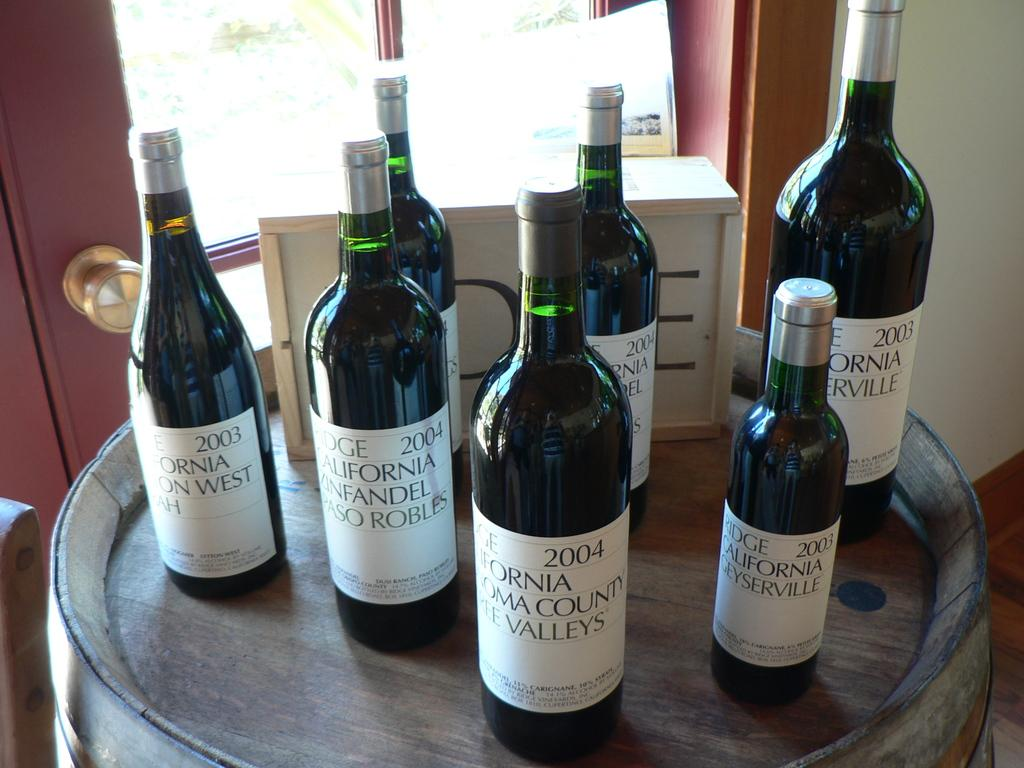<image>
Describe the image concisely. Several bottles of wine are on a table together, including bottles from 2003 and 2004. 